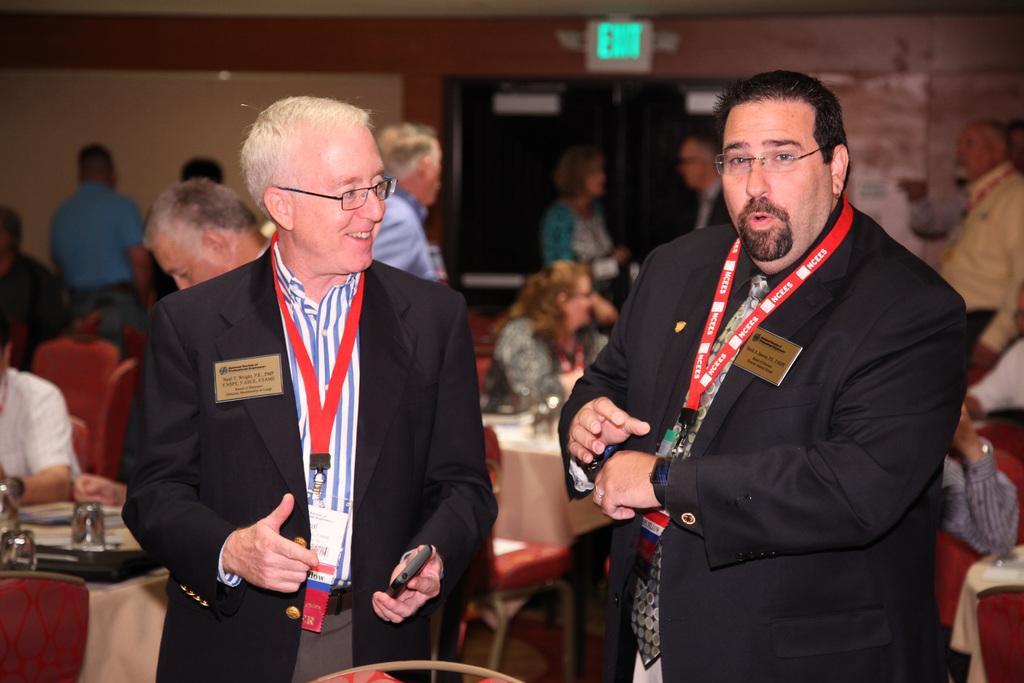Could you give a brief overview of what you see in this image? In this image, I can see a group of people are sitting on the chairs in front of tables on which papers, some objects are kept and I can see few of them are standing on the floor. In the background, I can see a wall, board and a door. This image taken, maybe in a hall. 